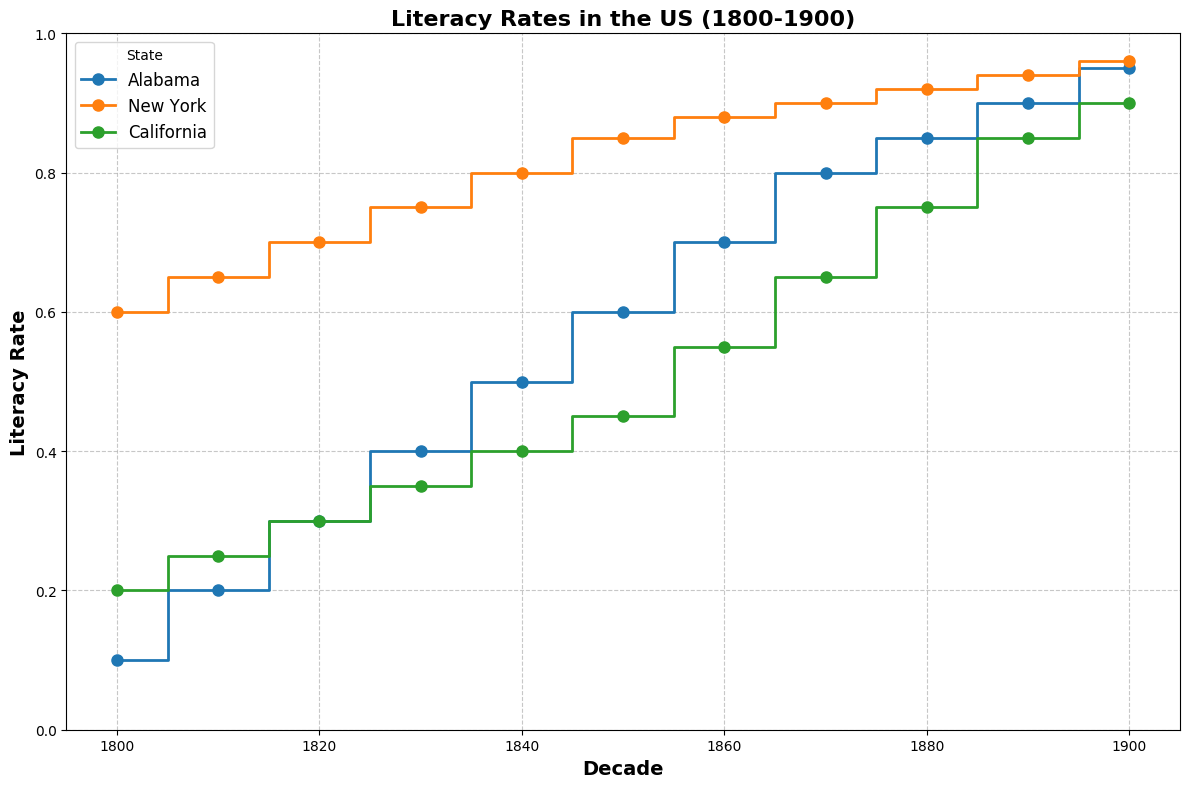What is the literacy rate in California in 1860? Locate California on the plot and find the value on the y-axis at the 1860 mark.
Answer: 0.55 Which state had the highest literacy rate in 1800? Compare the literacy rates of Alabama, New York, and California for the 1800 data point. New York's rate is the highest.
Answer: New York Which state showed the greatest increase in literacy rate from 1800 to 1900? Calculate the difference in literacy rates for each state from 1800 to 1900. Alabama: 0.95 - 0.1 = 0.85, New York: 0.96 - 0.6 = 0.36, California: 0.9 - 0.2 = 0.7. Alabama has the greatest increase.
Answer: Alabama What is the average literacy rate in New York across all the decades? Sum the literacy rates for New York and divide by the number of decades: (0.6 + 0.65 + 0.7 + 0.75 + 0.8 + 0.85 + 0.88 + 0.9 + 0.92 + 0.94 + 0.96) / 11 = 0.8
Answer: 0.8 Between which decades did Alabama experience the most significant increase in literacy rate? Identify the largest vertical step in the plot for Alabama: Alabama's largest increase is from 1860 to 1870 (0.7 to 0.8).
Answer: 1860 to 1870 Which state had the smallest change in literacy rate between 1800 and 1900? Calculate the difference in literacy rates for each state from 1800 to 1900. Alabama: 0.85, New York: 0.36, California: 0.7. New York has the smallest change.
Answer: New York Was the literacy rate of Alabama ever higher than that of California throughout these decades? Look at the plot and compare the literacy rates for Alabama and California across all decades. At each decade interval, California has equal or higher rates compared to Alabama.
Answer: No During which decade did California's literacy rate surpass 0.5? Examine the points on California's line plot to see when the literacy rate first exceeds 0.5. This happens between the 1850s and 1860s.
Answer: 1860 By how much did New York's literacy rate increase from 1850 to 1860? Subtract New York's literacy rate in 1850 from the rate in 1860: 0.88 - 0.85 = 0.03
Answer: 0.03 